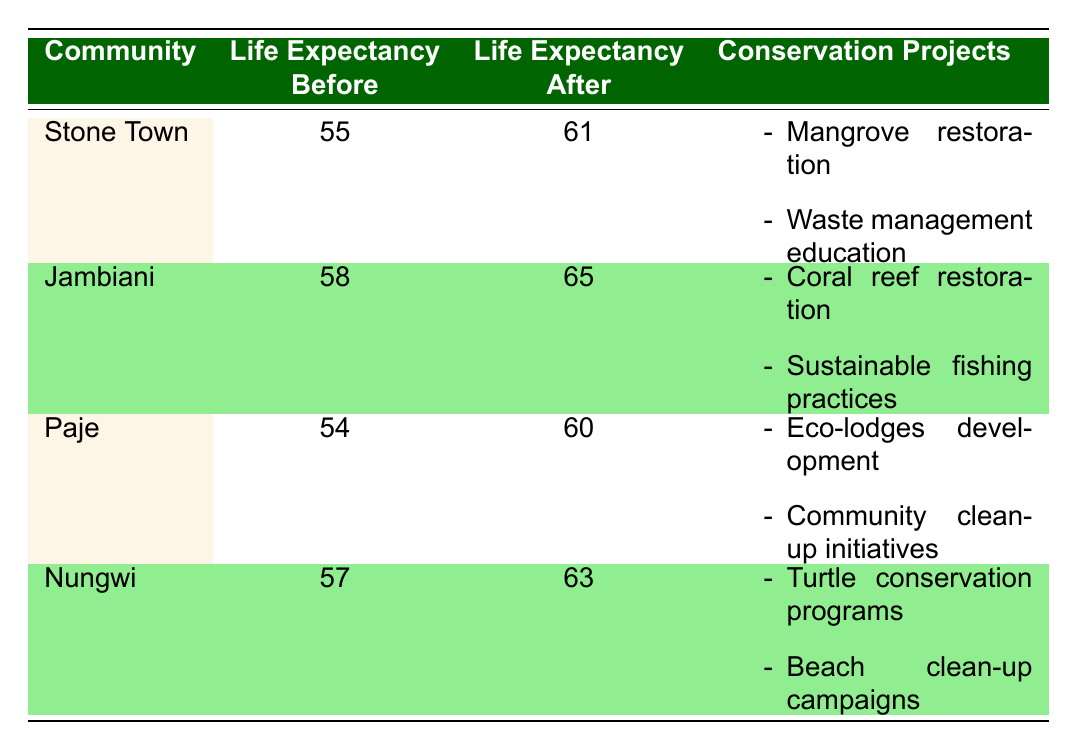What was the life expectancy in Jambiani before the conservation efforts? The table lists the life expectancy values for each community. Jambiani's life expectancy before conservation efforts is specified as 58 years.
Answer: 58 What conservation projects were implemented in Stone Town? Looking at the conservation projects listed for Stone Town, the table states there were two initiatives: mangrove restoration and waste management education.
Answer: Mangrove restoration, waste management education What was the increase in life expectancy after conservation efforts in Nungwi? The table shows Nungwi's life expectancy before conservation efforts was 57 years and after was 63 years. The increase can be calculated as 63 - 57 = 6 years.
Answer: 6 years In which community did life expectancy improve the most after conservation efforts? The changes in life expectancy can be calculated: Stone Town improved by 6 years (61 - 55), Jambiani improved by 7 years (65 - 58), Paje improved by 6 years (60 - 54), and Nungwi improved by 6 years (63 - 57). Therefore, Jambiani had the highest improvement at 7 years.
Answer: Jambiani Did Paje implement any health education workshops as part of their conservation efforts? The text under Paje states that there were enhancements in mental health through eco-tourism and a lower incidence of respiratory diseases, but it does not mention health education workshops. Thus, this is false.
Answer: No What was the average life expectancy increase across all communities listed? To find the average increase, we first calculate the individual improvements: Stone Town (6), Jambiani (7), Paje (6), Nungwi (6). Adding these gives a total of 25 years. Since there are 4 communities, the average increase is calculated as 25/4 = 6.25 years.
Answer: 6.25 years What health improvements were observed after the conservation efforts in Jambiani? The table specifies that in Jambiani, the health improvements included increased food security and health education workshops.
Answer: Increased food security, health education workshops Is it true that all communities experienced an increase in life expectancy after the conservation projects? Reviewing the life expectancy values before and after the conservation projects, all communities—Stone Town, Jambiani, Paje, and Nungwi—showed an increase. Therefore, this statement is true.
Answer: Yes 